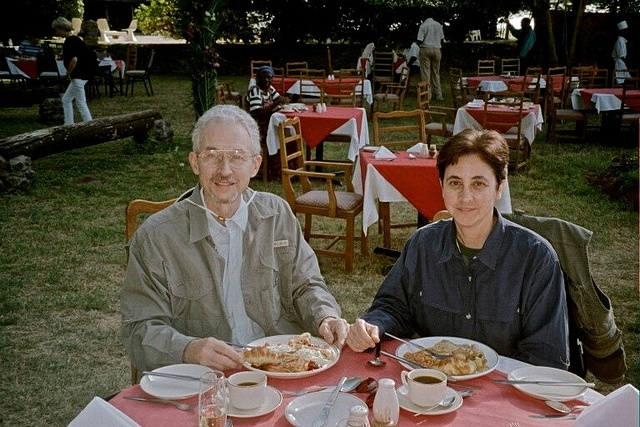Describe the objects in this image and their specific colors. I can see people in black, gray, and darkgray tones, dining table in black, darkgray, brown, maroon, and tan tones, people in black, gray, and tan tones, chair in black, maroon, gray, and darkgreen tones, and chair in black, maroon, olive, and gray tones in this image. 